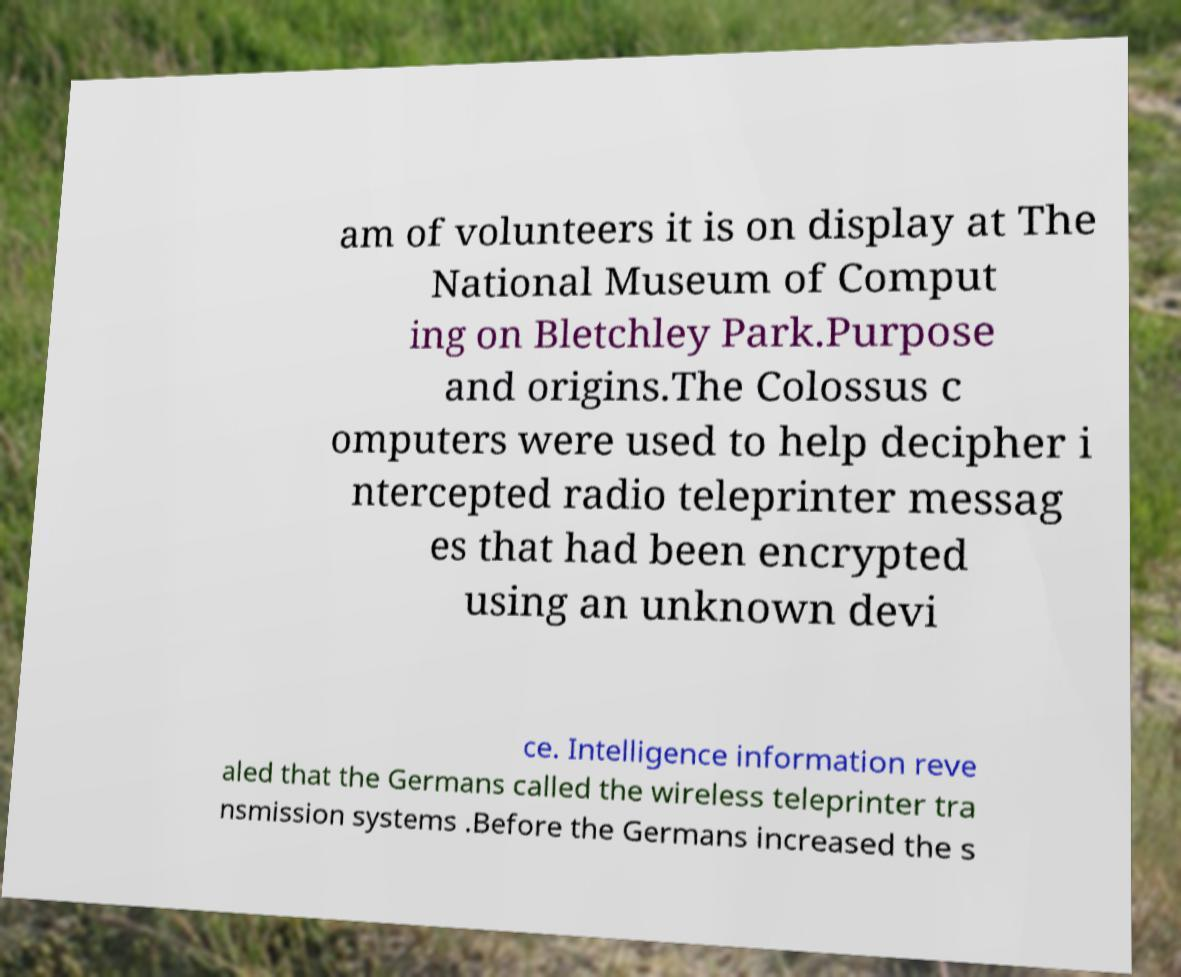Can you accurately transcribe the text from the provided image for me? am of volunteers it is on display at The National Museum of Comput ing on Bletchley Park.Purpose and origins.The Colossus c omputers were used to help decipher i ntercepted radio teleprinter messag es that had been encrypted using an unknown devi ce. Intelligence information reve aled that the Germans called the wireless teleprinter tra nsmission systems .Before the Germans increased the s 